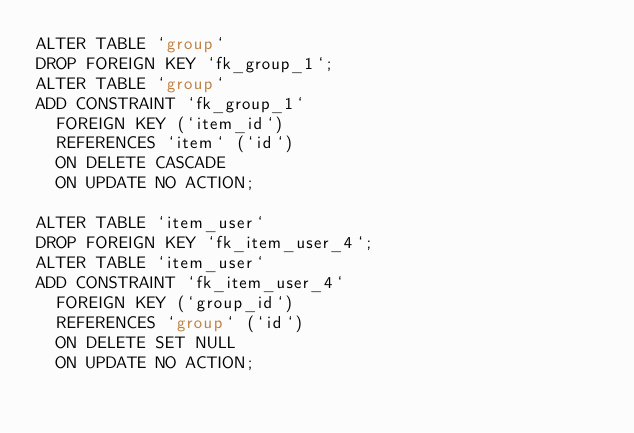Convert code to text. <code><loc_0><loc_0><loc_500><loc_500><_SQL_>ALTER TABLE `group` 
DROP FOREIGN KEY `fk_group_1`;
ALTER TABLE `group` 
ADD CONSTRAINT `fk_group_1`
  FOREIGN KEY (`item_id`)
  REFERENCES `item` (`id`)
  ON DELETE CASCADE
  ON UPDATE NO ACTION;

ALTER TABLE `item_user`
DROP FOREIGN KEY `fk_item_user_4`;
ALTER TABLE `item_user`
ADD CONSTRAINT `fk_item_user_4`
  FOREIGN KEY (`group_id`)
  REFERENCES `group` (`id`)
  ON DELETE SET NULL
  ON UPDATE NO ACTION;

</code> 